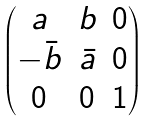<formula> <loc_0><loc_0><loc_500><loc_500>\begin{pmatrix} a & b & 0 \\ - \bar { b } & \bar { a } & 0 \\ 0 & 0 & 1 \end{pmatrix}</formula> 